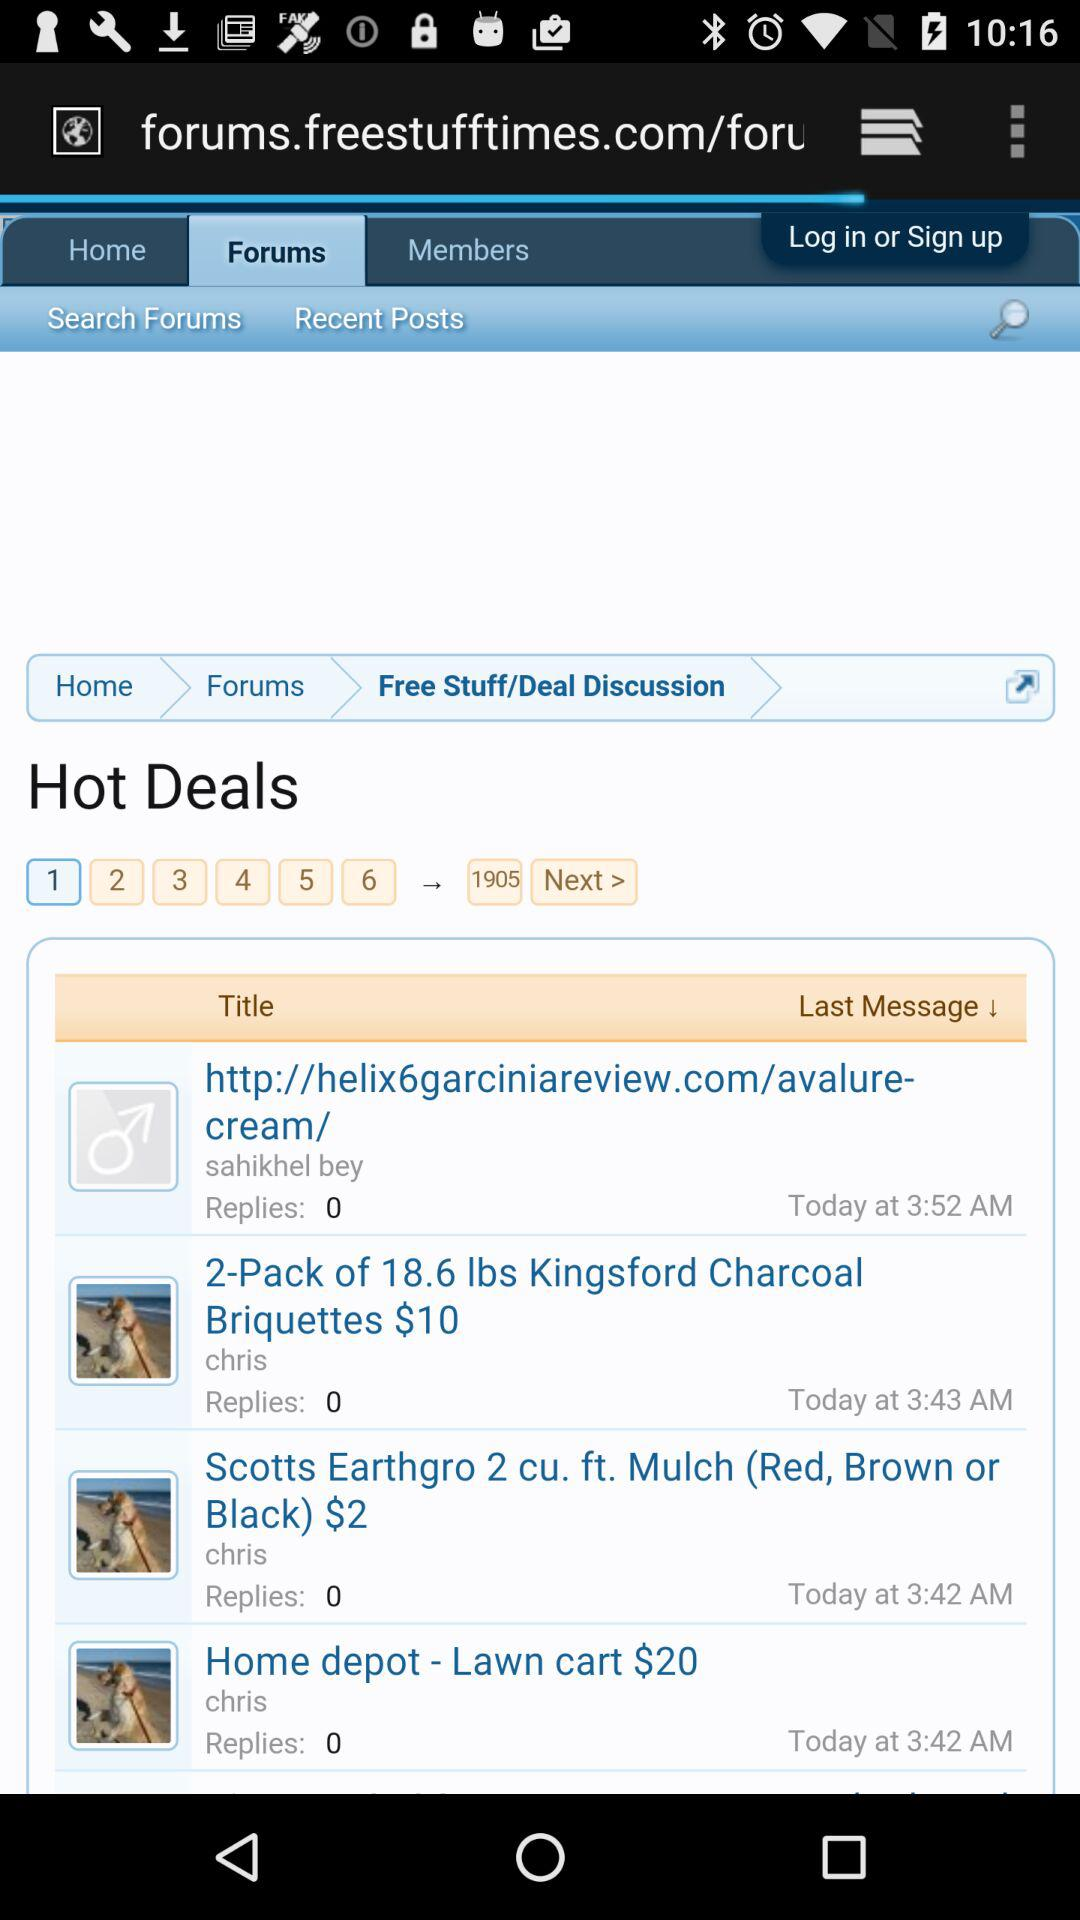Which option has been selected? The selected options are "Forums" and "1". 